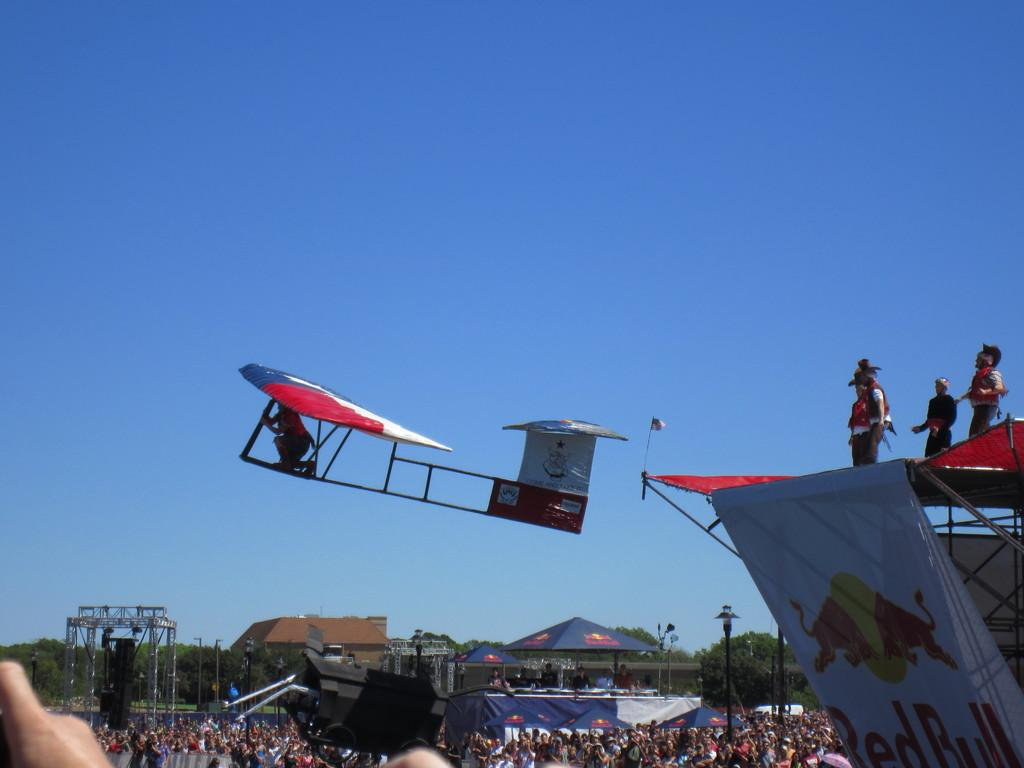<image>
Provide a brief description of the given image. A glider flying over a crowd says "come and take it" on the tail. 